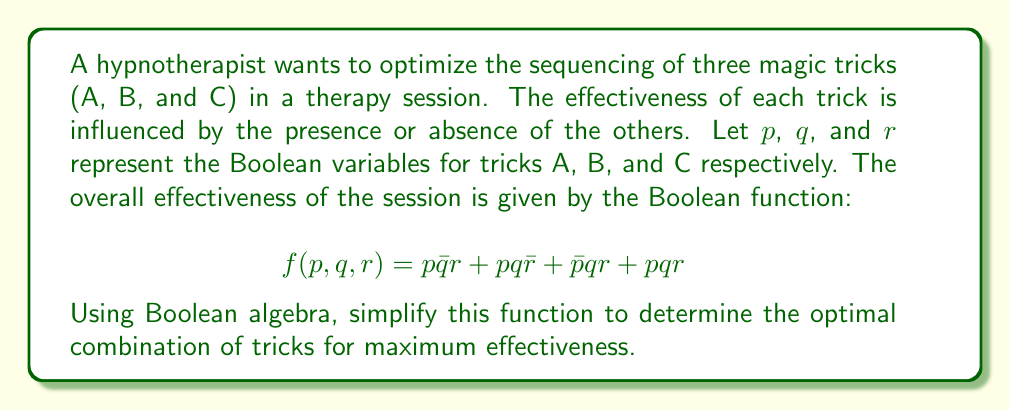Teach me how to tackle this problem. To simplify the Boolean function, we'll use the laws of Boolean algebra:

1) First, let's group terms with $pq$:
   $$f(p,q,r) = p\bar{q}r + (pq\bar{r} + pqr) + \bar{p}qr$$

2) Simplify the grouped term using the distributive law:
   $$f(p,q,r) = p\bar{q}r + pq(\bar{r} + r) + \bar{p}qr$$

3) Simplify $(\bar{r} + r) = 1$ (law of complementation):
   $$f(p,q,r) = p\bar{q}r + pq + \bar{p}qr$$

4) Group terms with $r$:
   $$f(p,q,r) = pq + r(p\bar{q} + \bar{p}q)$$

5) The term $(p\bar{q} + \bar{p}q)$ is the exclusive OR of $p$ and $q$, which we can write as $p \oplus q$:
   $$f(p,q,r) = pq + r(p \oplus q)$$

This is the simplified Boolean function. It shows that the session is effective when either:
- Tricks A and B are both performed (regardless of C), or
- Trick C is performed along with either A or B, but not both.
Answer: $pq + r(p \oplus q)$ 